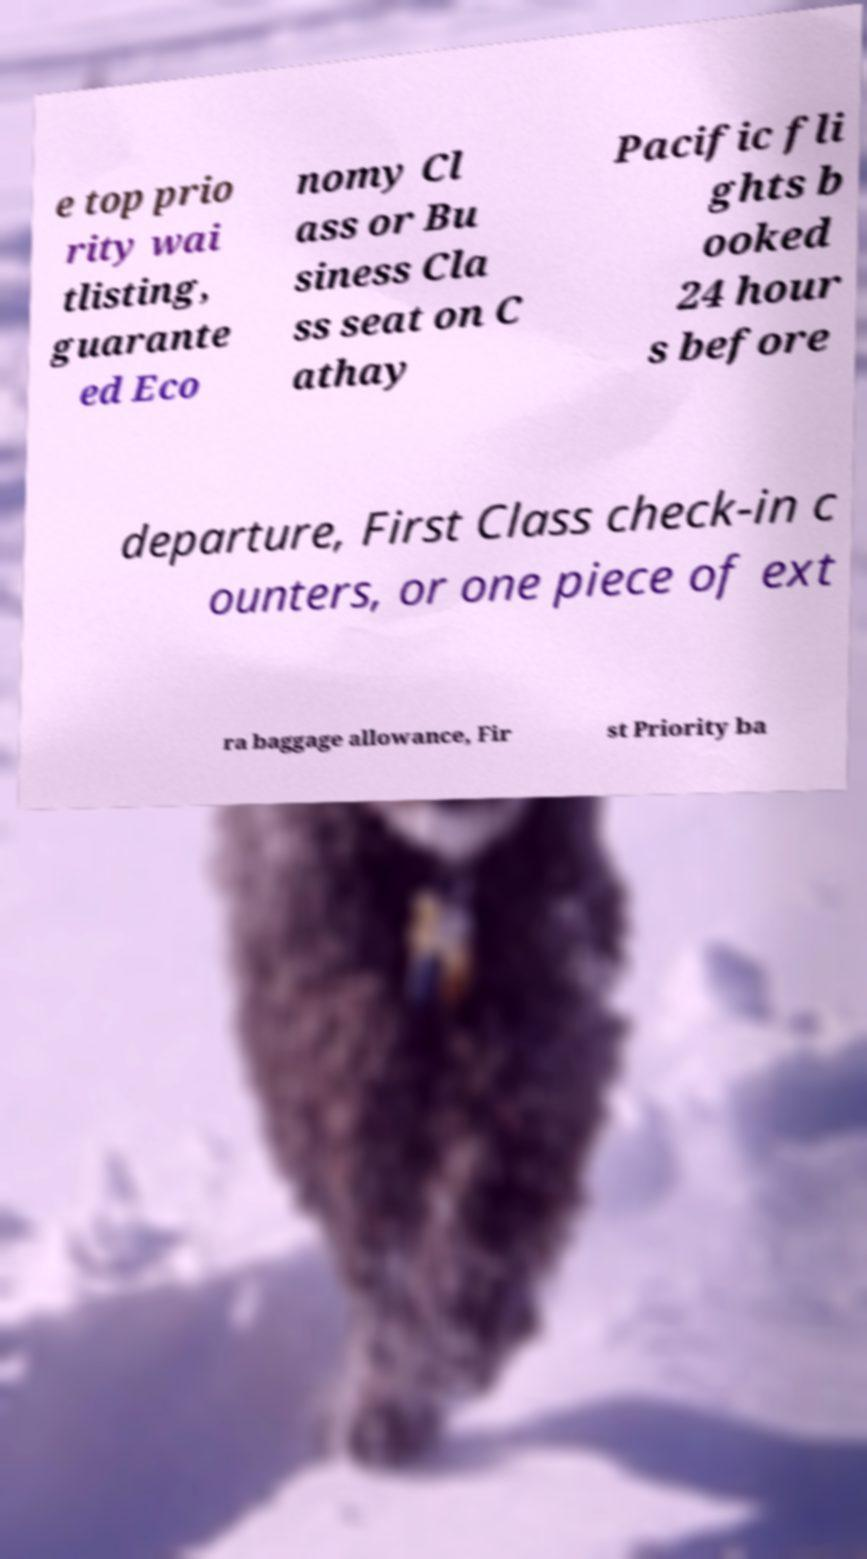There's text embedded in this image that I need extracted. Can you transcribe it verbatim? e top prio rity wai tlisting, guarante ed Eco nomy Cl ass or Bu siness Cla ss seat on C athay Pacific fli ghts b ooked 24 hour s before departure, First Class check-in c ounters, or one piece of ext ra baggage allowance, Fir st Priority ba 